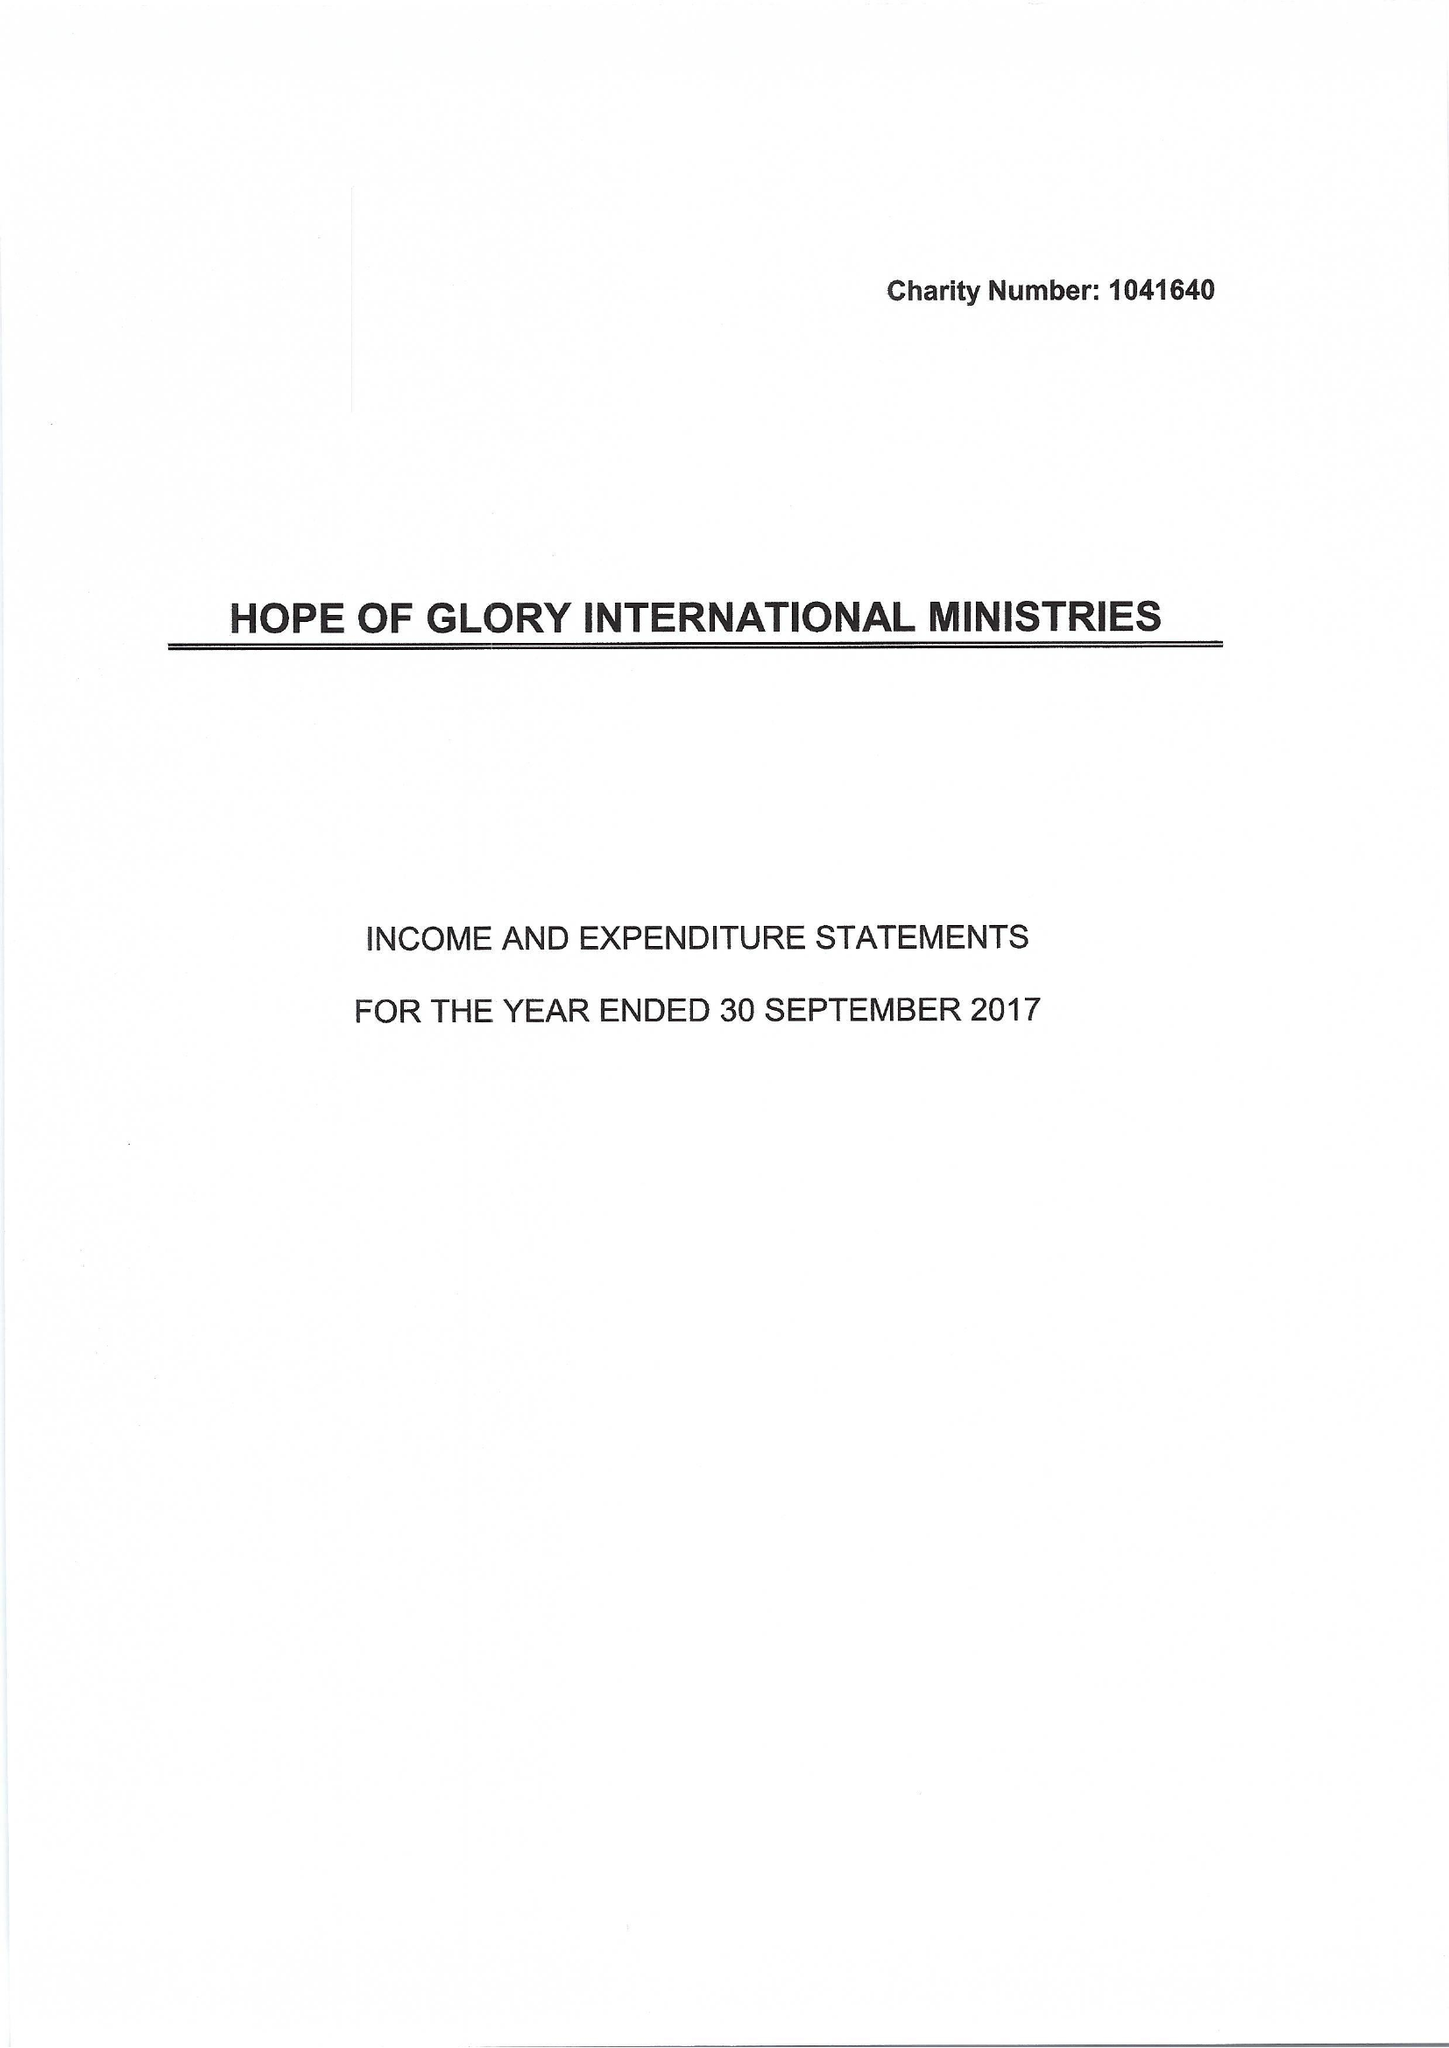What is the value for the address__postcode?
Answer the question using a single word or phrase. DA7 4NR 